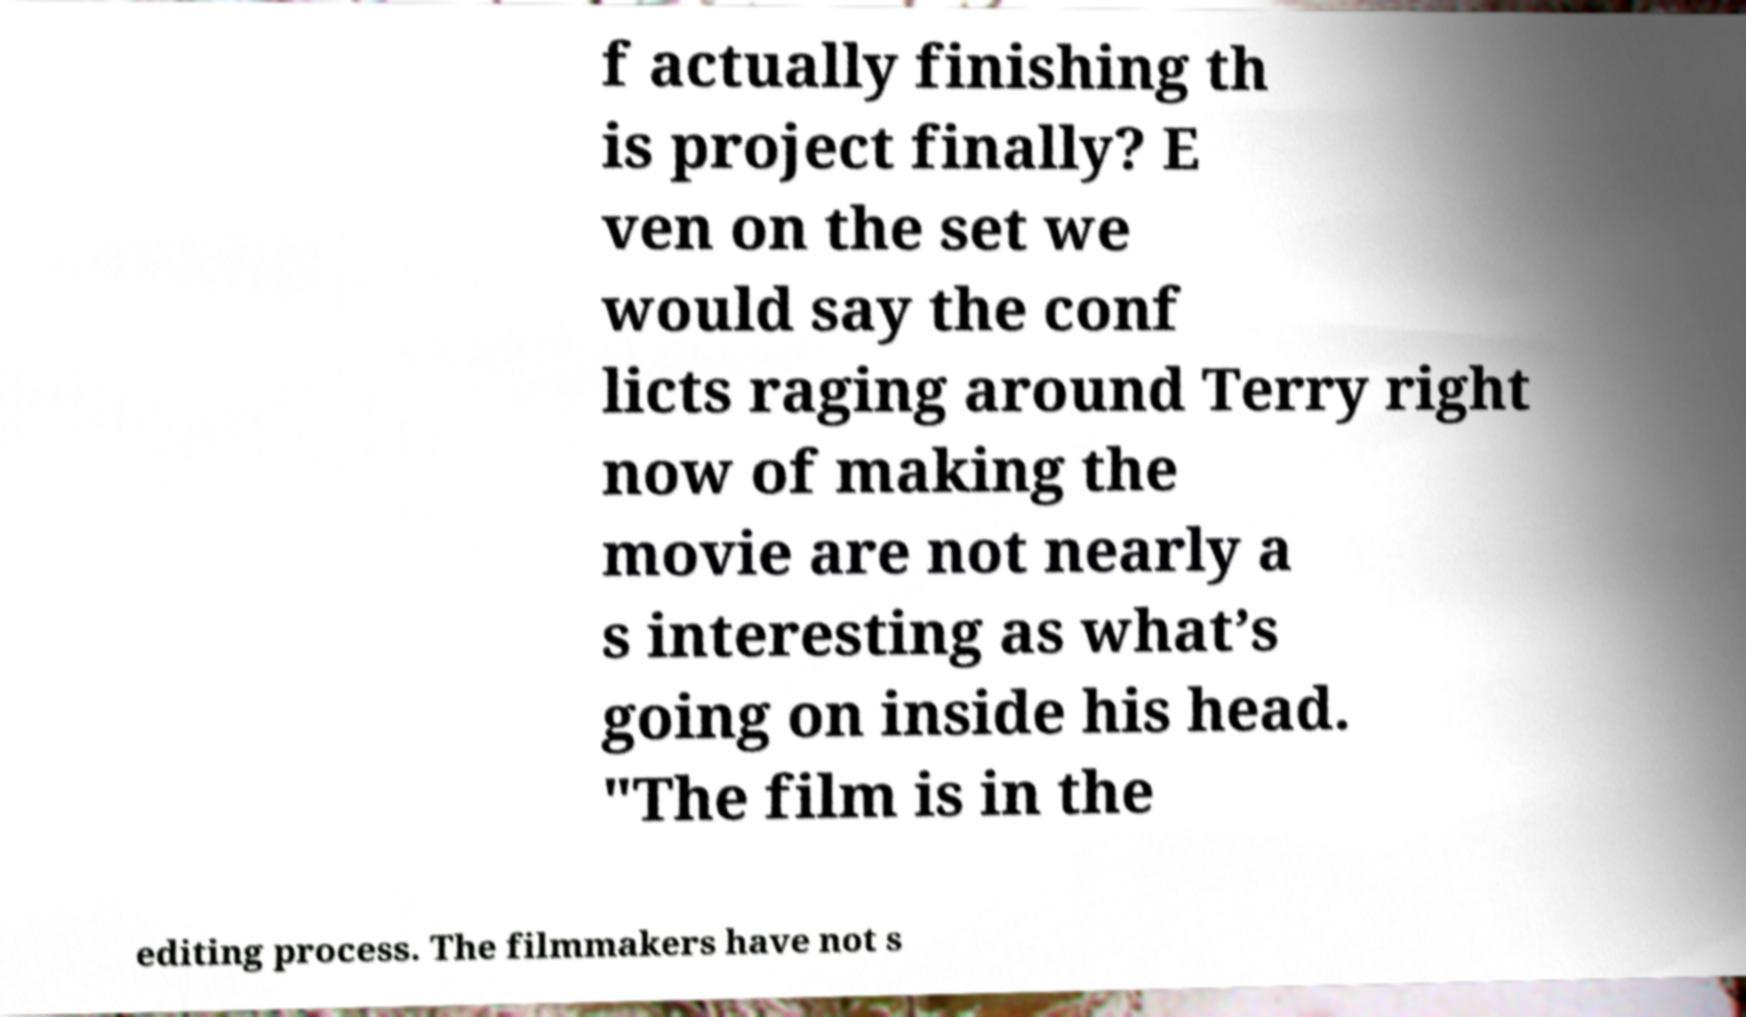What messages or text are displayed in this image? I need them in a readable, typed format. f actually finishing th is project finally? E ven on the set we would say the conf licts raging around Terry right now of making the movie are not nearly a s interesting as what’s going on inside his head. "The film is in the editing process. The filmmakers have not s 